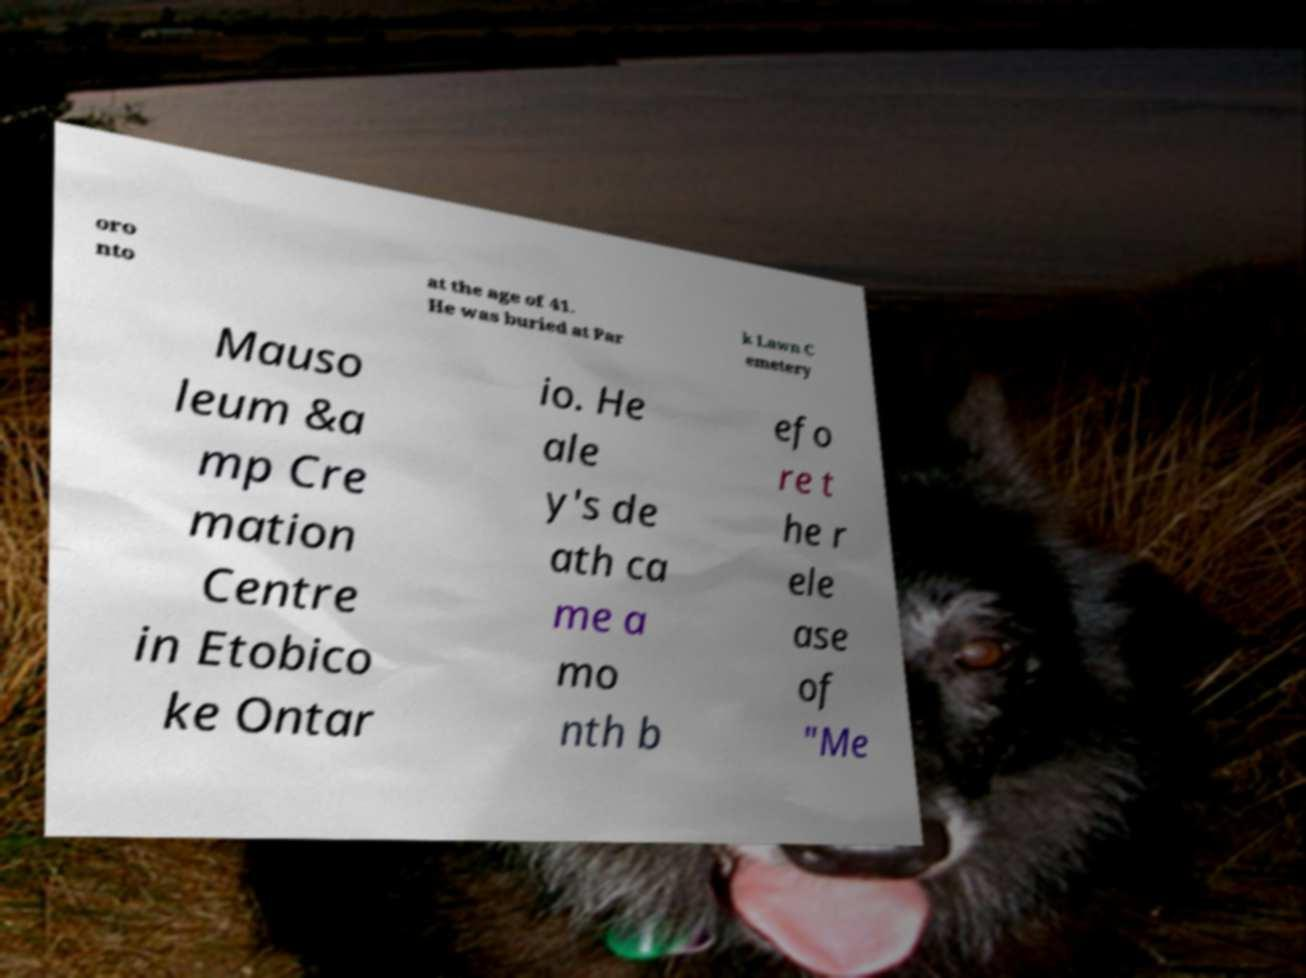Please read and relay the text visible in this image. What does it say? oro nto at the age of 41. He was buried at Par k Lawn C emetery Mauso leum &a mp Cre mation Centre in Etobico ke Ontar io. He ale y's de ath ca me a mo nth b efo re t he r ele ase of "Me 